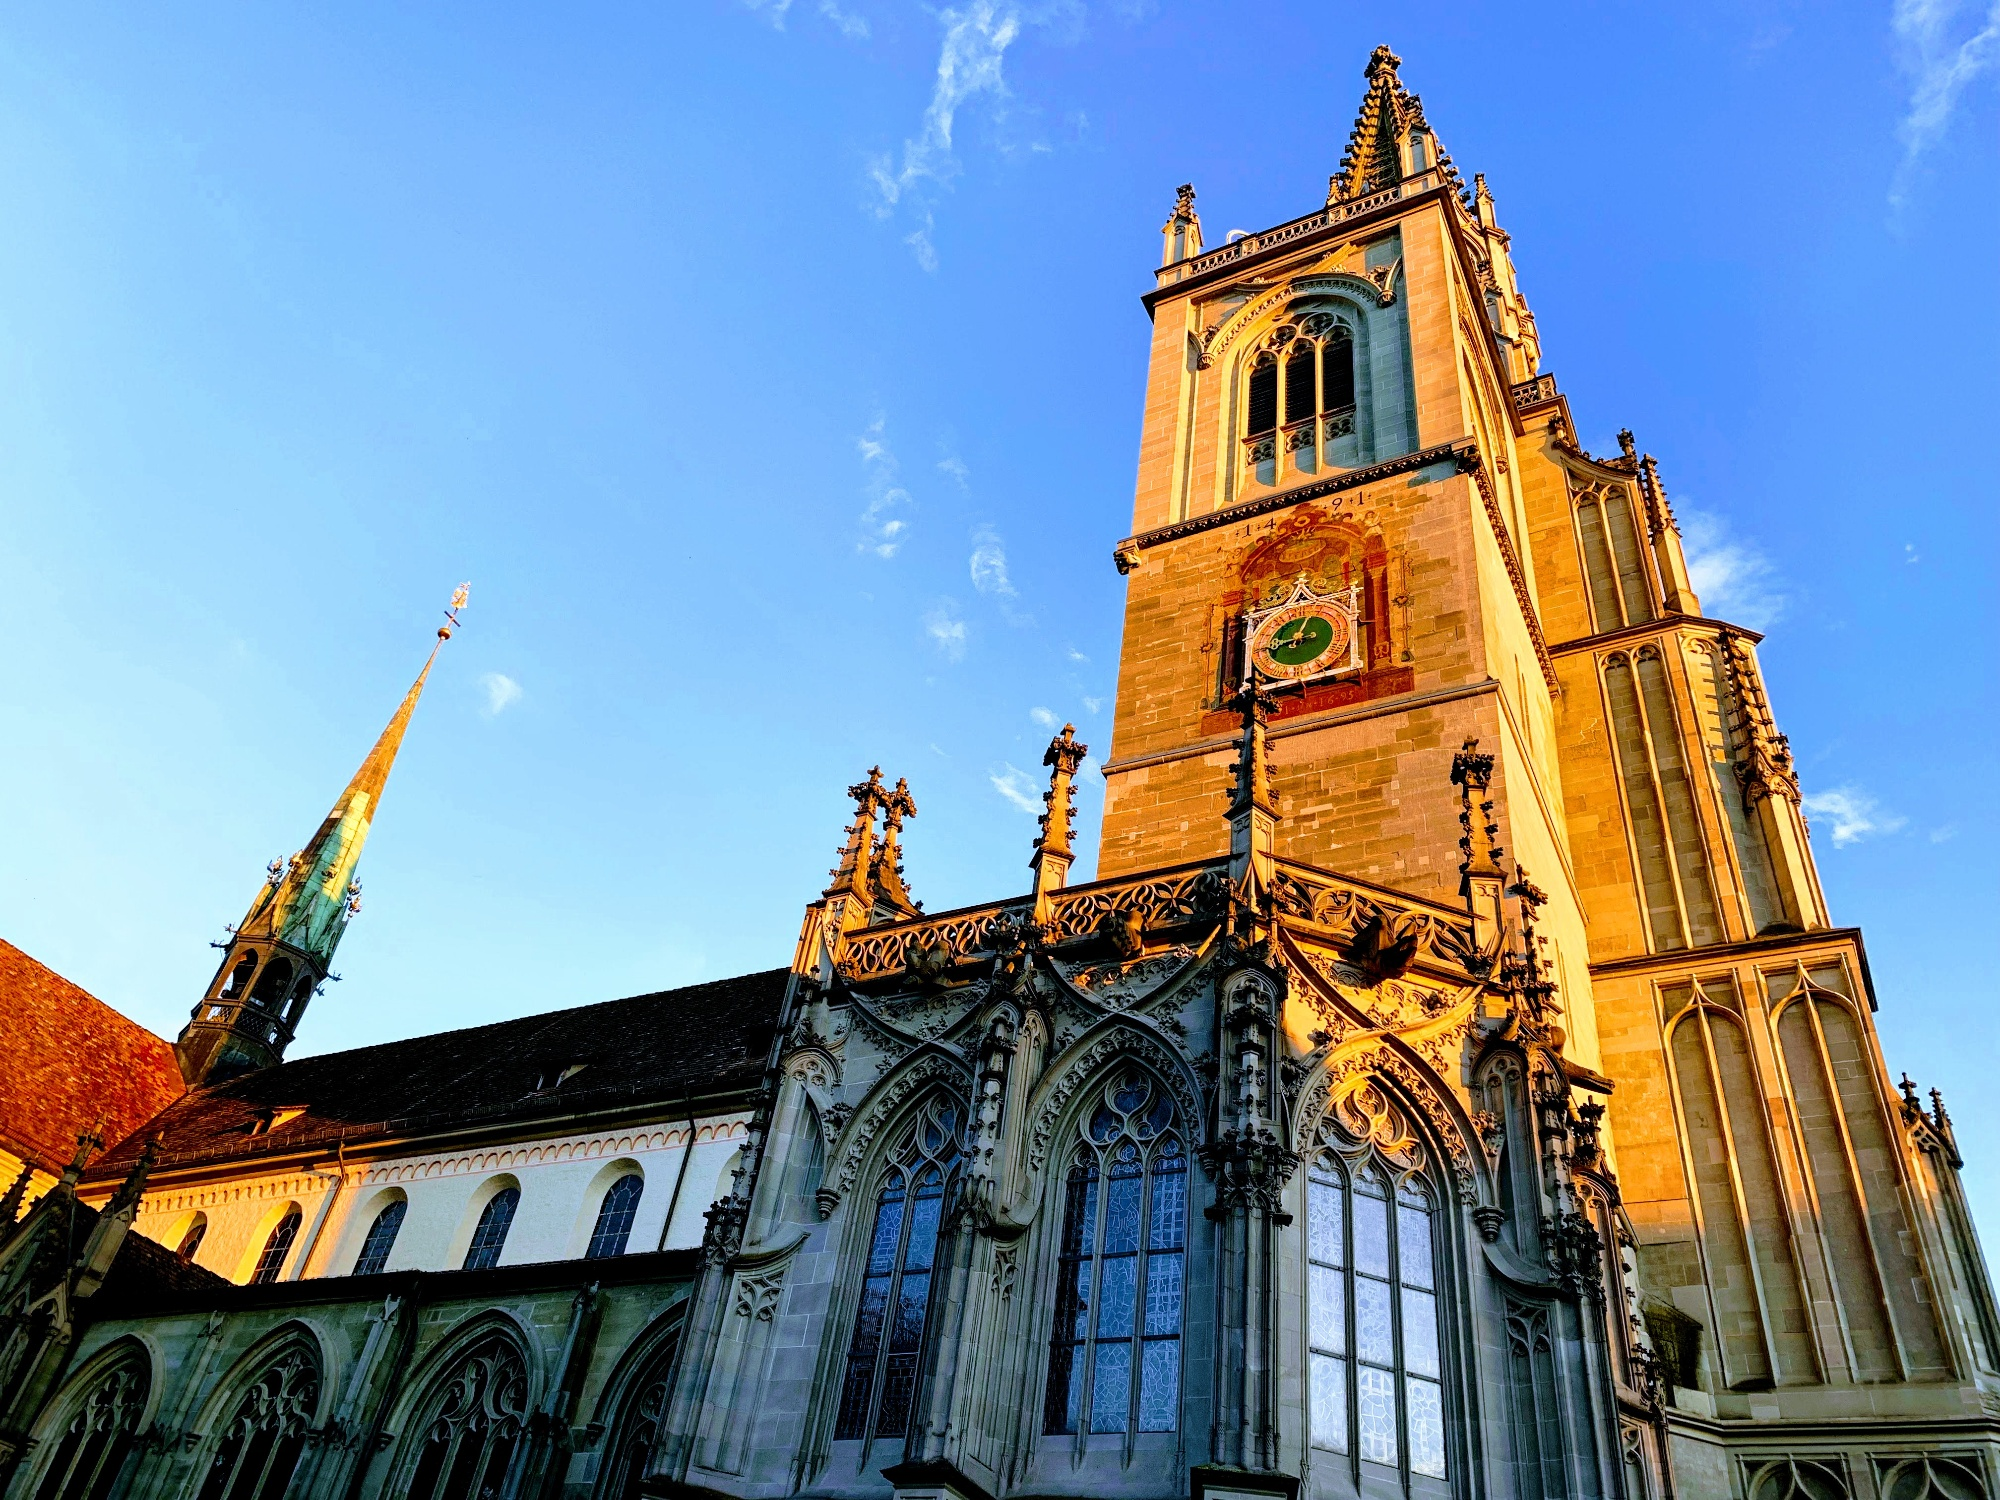If this cathedral could speak, what stories might it share? If Konstanz Minster could speak, it would share tales of centuries past - of monks and pilgrims, of royal decrees and historic councils. It would recount the hushed whispers of secret meetings during the Council of Constance and the echoes of magnificent choirs singing through its vast halls. The cathedral would speak of the changing times, from its early days in the 7th century through the Middle Ages, bearing witness to the ebb and flow of human endeavors, triumphs, and tribulations. It would tell the stories of countless weddings, baptisms, and funerals, each etching a new chapter into its enduring stone walls. As a silent observer, the Minster holds within its walls the collective memory of a community, its joys, sorrows, and resilience through the ages. 